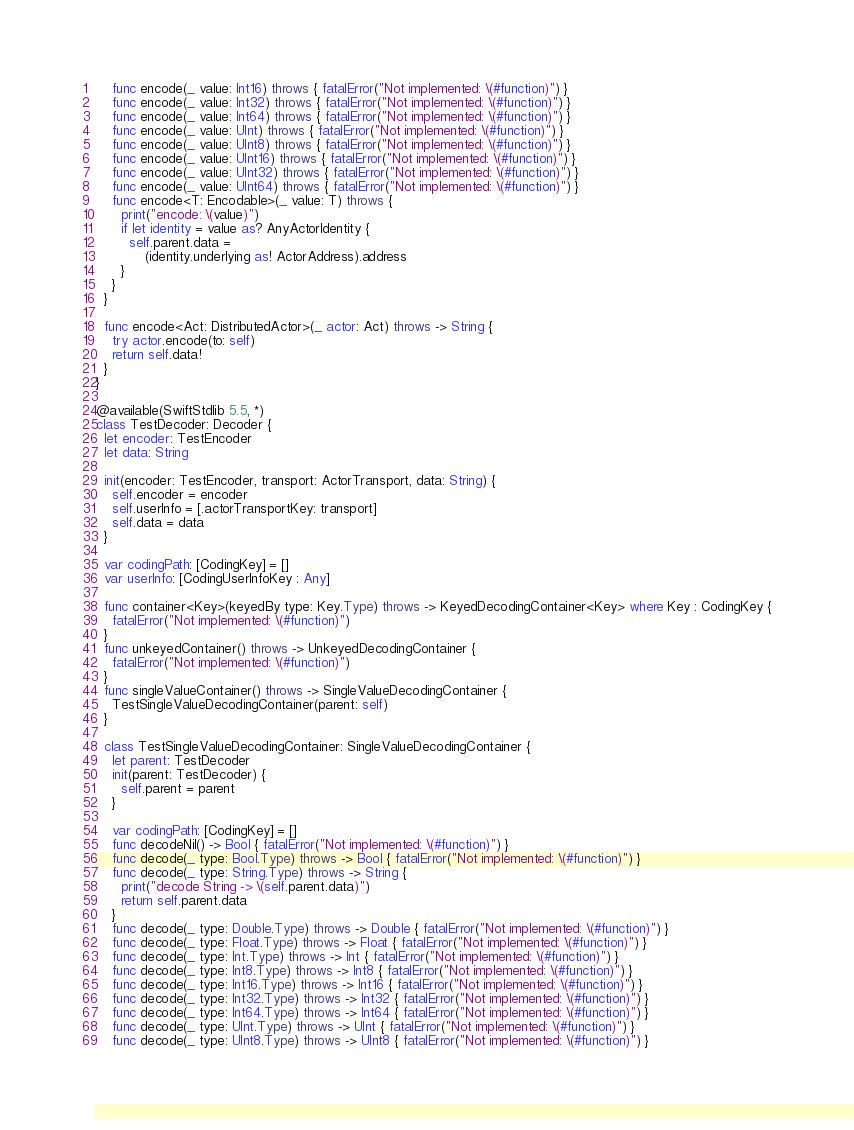Convert code to text. <code><loc_0><loc_0><loc_500><loc_500><_Swift_>    func encode(_ value: Int16) throws { fatalError("Not implemented: \(#function)") }
    func encode(_ value: Int32) throws { fatalError("Not implemented: \(#function)") }
    func encode(_ value: Int64) throws { fatalError("Not implemented: \(#function)") }
    func encode(_ value: UInt) throws { fatalError("Not implemented: \(#function)") }
    func encode(_ value: UInt8) throws { fatalError("Not implemented: \(#function)") }
    func encode(_ value: UInt16) throws { fatalError("Not implemented: \(#function)") }
    func encode(_ value: UInt32) throws { fatalError("Not implemented: \(#function)") }
    func encode(_ value: UInt64) throws { fatalError("Not implemented: \(#function)") }
    func encode<T: Encodable>(_ value: T) throws {
      print("encode: \(value)")
      if let identity = value as? AnyActorIdentity {
        self.parent.data =
            (identity.underlying as! ActorAddress).address
      }
    }
  }

  func encode<Act: DistributedActor>(_ actor: Act) throws -> String {
    try actor.encode(to: self)
    return self.data!
  }
}

@available(SwiftStdlib 5.5, *)
class TestDecoder: Decoder {
  let encoder: TestEncoder
  let data: String

  init(encoder: TestEncoder, transport: ActorTransport, data: String) {
    self.encoder = encoder
    self.userInfo = [.actorTransportKey: transport]
    self.data = data
  }

  var codingPath: [CodingKey] = []
  var userInfo: [CodingUserInfoKey : Any]

  func container<Key>(keyedBy type: Key.Type) throws -> KeyedDecodingContainer<Key> where Key : CodingKey {
    fatalError("Not implemented: \(#function)")
  }
  func unkeyedContainer() throws -> UnkeyedDecodingContainer {
    fatalError("Not implemented: \(#function)")
  }
  func singleValueContainer() throws -> SingleValueDecodingContainer {
    TestSingleValueDecodingContainer(parent: self)
  }

  class TestSingleValueDecodingContainer: SingleValueDecodingContainer {
    let parent: TestDecoder
    init(parent: TestDecoder) {
      self.parent = parent
    }

    var codingPath: [CodingKey] = []
    func decodeNil() -> Bool { fatalError("Not implemented: \(#function)") }
    func decode(_ type: Bool.Type) throws -> Bool { fatalError("Not implemented: \(#function)") }
    func decode(_ type: String.Type) throws -> String {
      print("decode String -> \(self.parent.data)")
      return self.parent.data
    }
    func decode(_ type: Double.Type) throws -> Double { fatalError("Not implemented: \(#function)") }
    func decode(_ type: Float.Type) throws -> Float { fatalError("Not implemented: \(#function)") }
    func decode(_ type: Int.Type) throws -> Int { fatalError("Not implemented: \(#function)") }
    func decode(_ type: Int8.Type) throws -> Int8 { fatalError("Not implemented: \(#function)") }
    func decode(_ type: Int16.Type) throws -> Int16 { fatalError("Not implemented: \(#function)") }
    func decode(_ type: Int32.Type) throws -> Int32 { fatalError("Not implemented: \(#function)") }
    func decode(_ type: Int64.Type) throws -> Int64 { fatalError("Not implemented: \(#function)") }
    func decode(_ type: UInt.Type) throws -> UInt { fatalError("Not implemented: \(#function)") }
    func decode(_ type: UInt8.Type) throws -> UInt8 { fatalError("Not implemented: \(#function)") }</code> 